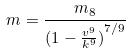<formula> <loc_0><loc_0><loc_500><loc_500>m = \frac { m _ { 8 } } { ( { 1 - \frac { v ^ { 9 } } { k ^ { 9 } } ) } ^ { 7 / 9 } }</formula> 